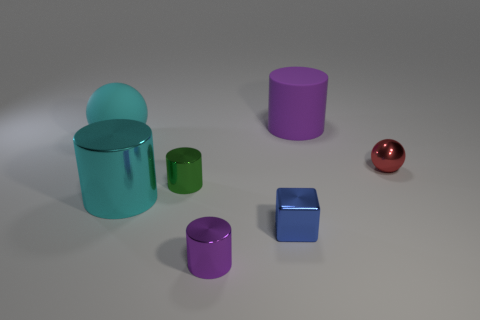Add 1 large cyan metal objects. How many objects exist? 8 Subtract all spheres. How many objects are left? 5 Subtract all tiny blue things. Subtract all small blue cubes. How many objects are left? 5 Add 6 tiny purple cylinders. How many tiny purple cylinders are left? 7 Add 5 tiny yellow cylinders. How many tiny yellow cylinders exist? 5 Subtract 0 brown blocks. How many objects are left? 7 